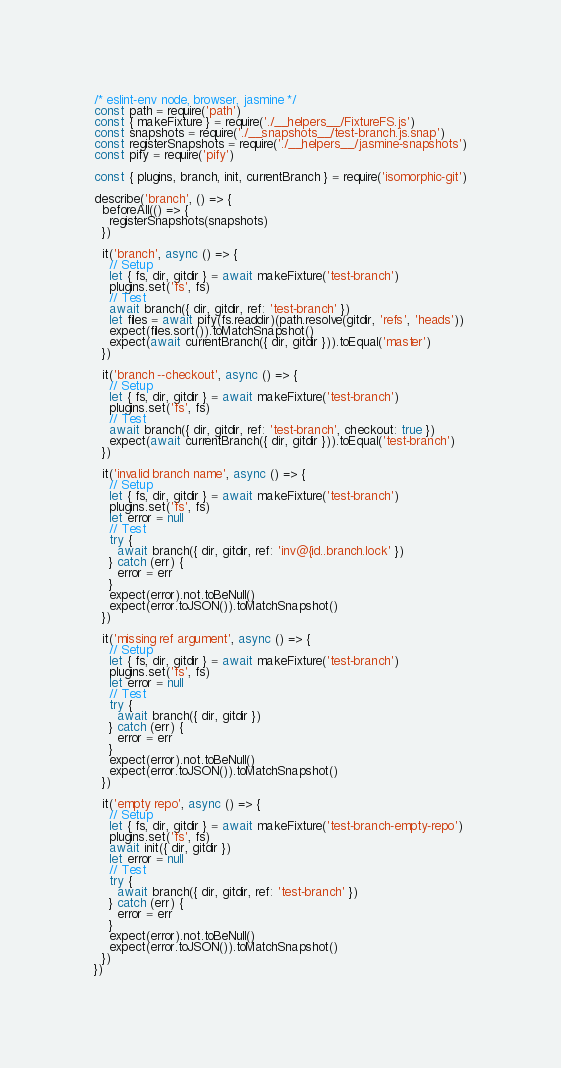<code> <loc_0><loc_0><loc_500><loc_500><_JavaScript_>/* eslint-env node, browser, jasmine */
const path = require('path')
const { makeFixture } = require('./__helpers__/FixtureFS.js')
const snapshots = require('./__snapshots__/test-branch.js.snap')
const registerSnapshots = require('./__helpers__/jasmine-snapshots')
const pify = require('pify')

const { plugins, branch, init, currentBranch } = require('isomorphic-git')

describe('branch', () => {
  beforeAll(() => {
    registerSnapshots(snapshots)
  })

  it('branch', async () => {
    // Setup
    let { fs, dir, gitdir } = await makeFixture('test-branch')
    plugins.set('fs', fs)
    // Test
    await branch({ dir, gitdir, ref: 'test-branch' })
    let files = await pify(fs.readdir)(path.resolve(gitdir, 'refs', 'heads'))
    expect(files.sort()).toMatchSnapshot()
    expect(await currentBranch({ dir, gitdir })).toEqual('master')
  })

  it('branch --checkout', async () => {
    // Setup
    let { fs, dir, gitdir } = await makeFixture('test-branch')
    plugins.set('fs', fs)
    // Test
    await branch({ dir, gitdir, ref: 'test-branch', checkout: true })
    expect(await currentBranch({ dir, gitdir })).toEqual('test-branch')
  })

  it('invalid branch name', async () => {
    // Setup
    let { fs, dir, gitdir } = await makeFixture('test-branch')
    plugins.set('fs', fs)
    let error = null
    // Test
    try {
      await branch({ dir, gitdir, ref: 'inv@{id..branch.lock' })
    } catch (err) {
      error = err
    }
    expect(error).not.toBeNull()
    expect(error.toJSON()).toMatchSnapshot()
  })

  it('missing ref argument', async () => {
    // Setup
    let { fs, dir, gitdir } = await makeFixture('test-branch')
    plugins.set('fs', fs)
    let error = null
    // Test
    try {
      await branch({ dir, gitdir })
    } catch (err) {
      error = err
    }
    expect(error).not.toBeNull()
    expect(error.toJSON()).toMatchSnapshot()
  })

  it('empty repo', async () => {
    // Setup
    let { fs, dir, gitdir } = await makeFixture('test-branch-empty-repo')
    plugins.set('fs', fs)
    await init({ dir, gitdir })
    let error = null
    // Test
    try {
      await branch({ dir, gitdir, ref: 'test-branch' })
    } catch (err) {
      error = err
    }
    expect(error).not.toBeNull()
    expect(error.toJSON()).toMatchSnapshot()
  })
})
</code> 